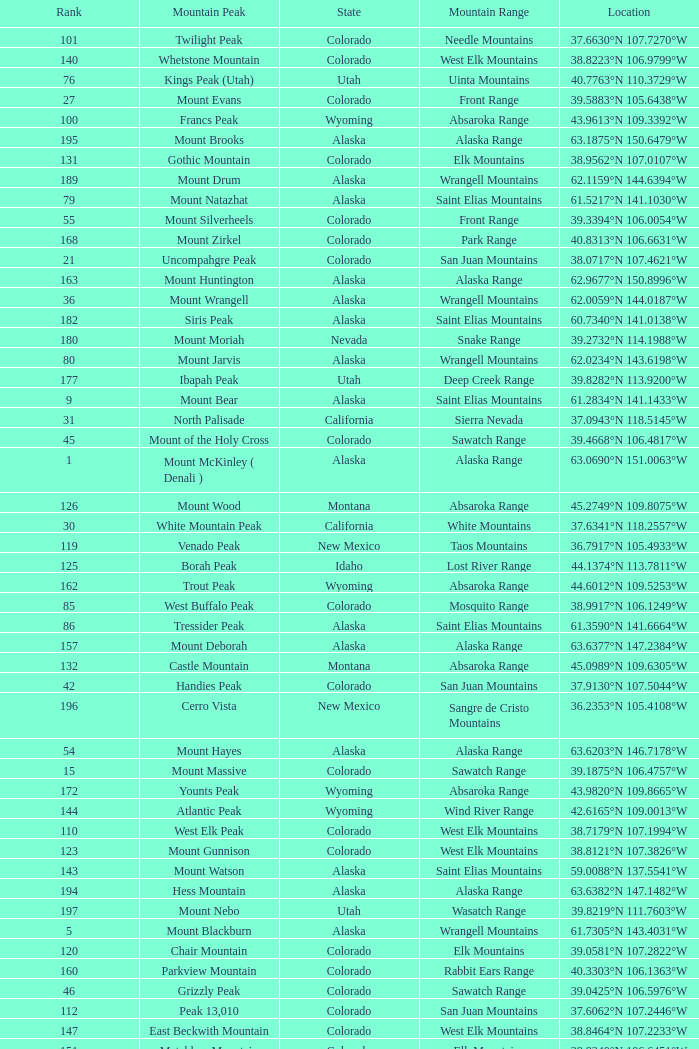What is the rank when the state is colorado and the location is 37.7859°n 107.7039°w? 83.0. 